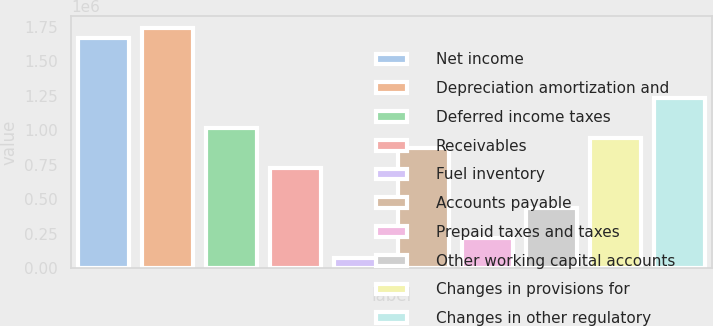Convert chart to OTSL. <chart><loc_0><loc_0><loc_500><loc_500><bar_chart><fcel>Net income<fcel>Depreciation amortization and<fcel>Deferred income taxes<fcel>Receivables<fcel>Fuel inventory<fcel>Accounts payable<fcel>Prepaid taxes and taxes<fcel>Other working capital accounts<fcel>Changes in provisions for<fcel>Changes in other regulatory<nl><fcel>1.66902e+06<fcel>1.74155e+06<fcel>1.01625e+06<fcel>726130<fcel>73357.3<fcel>871191<fcel>218418<fcel>436009<fcel>943721<fcel>1.23384e+06<nl></chart> 